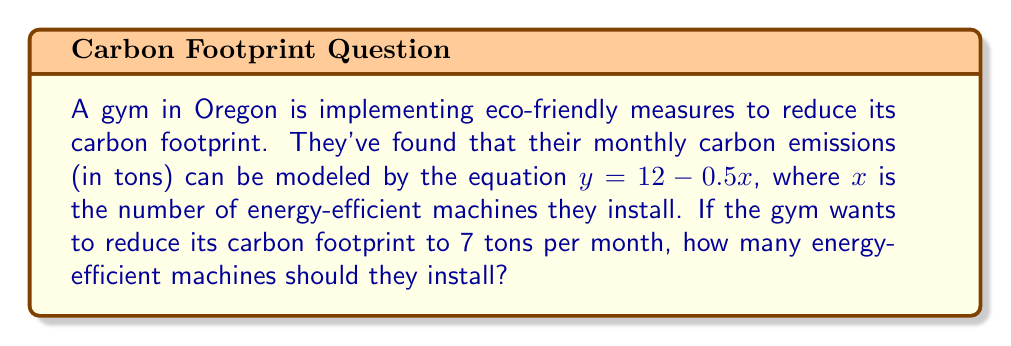Provide a solution to this math problem. Let's solve this problem step by step using the given linear equation:

1) The equation is $y = 12 - 0.5x$, where:
   $y$ = monthly carbon emissions in tons
   $x$ = number of energy-efficient machines installed

2) We want to find $x$ when $y = 7$ tons. So, let's substitute $y$ with 7:

   $7 = 12 - 0.5x$

3) Subtract 12 from both sides:

   $-5 = -0.5x$

4) Divide both sides by -0.5:

   $10 = x$

5) Therefore, the gym needs to install 10 energy-efficient machines to reduce their carbon footprint to 7 tons per month.

6) We can verify this by plugging $x = 10$ back into the original equation:

   $y = 12 - 0.5(10) = 12 - 5 = 7$

This confirms our solution is correct.
Answer: 10 machines 